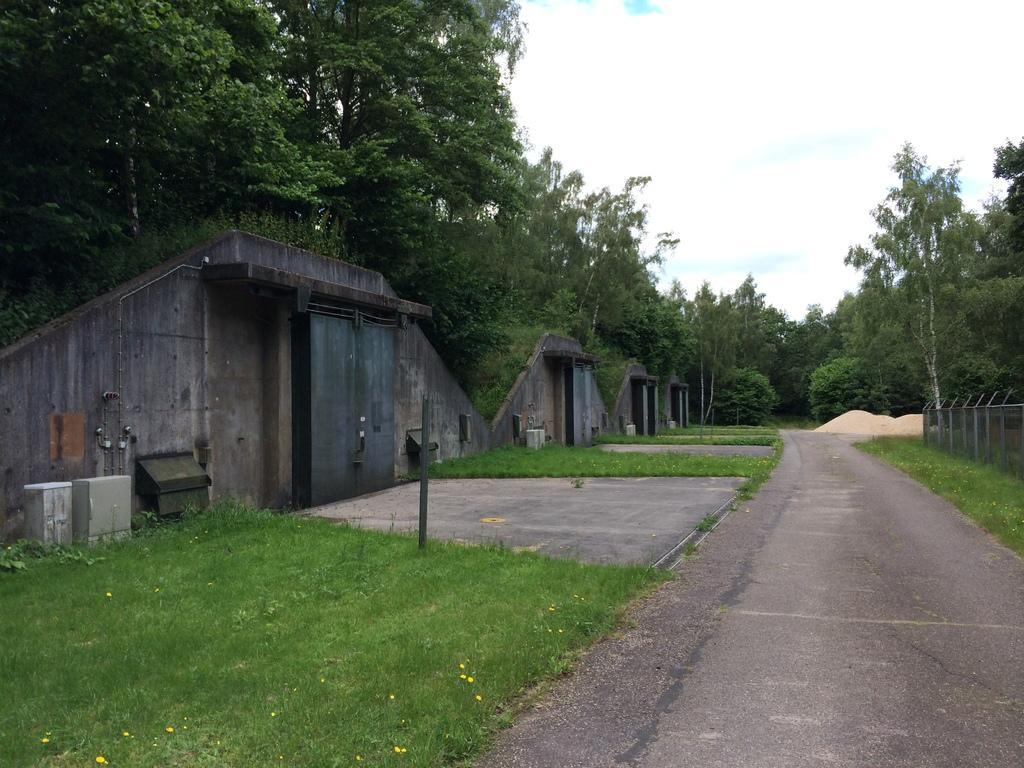Please provide a concise description of this image. In this image we can see there are trees, grass, fence, pole, boxes, sand, road and the sky. And there are walls with doors. 